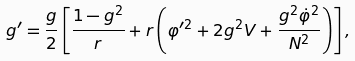Convert formula to latex. <formula><loc_0><loc_0><loc_500><loc_500>g ^ { \prime } = \frac { g } { 2 } \left [ \frac { 1 - g ^ { 2 } } r + r \left ( \varphi ^ { \prime 2 } + 2 g ^ { 2 } V + \frac { g ^ { 2 } \dot { \varphi } ^ { 2 } } { N ^ { 2 } } \right ) \right ] ,</formula> 